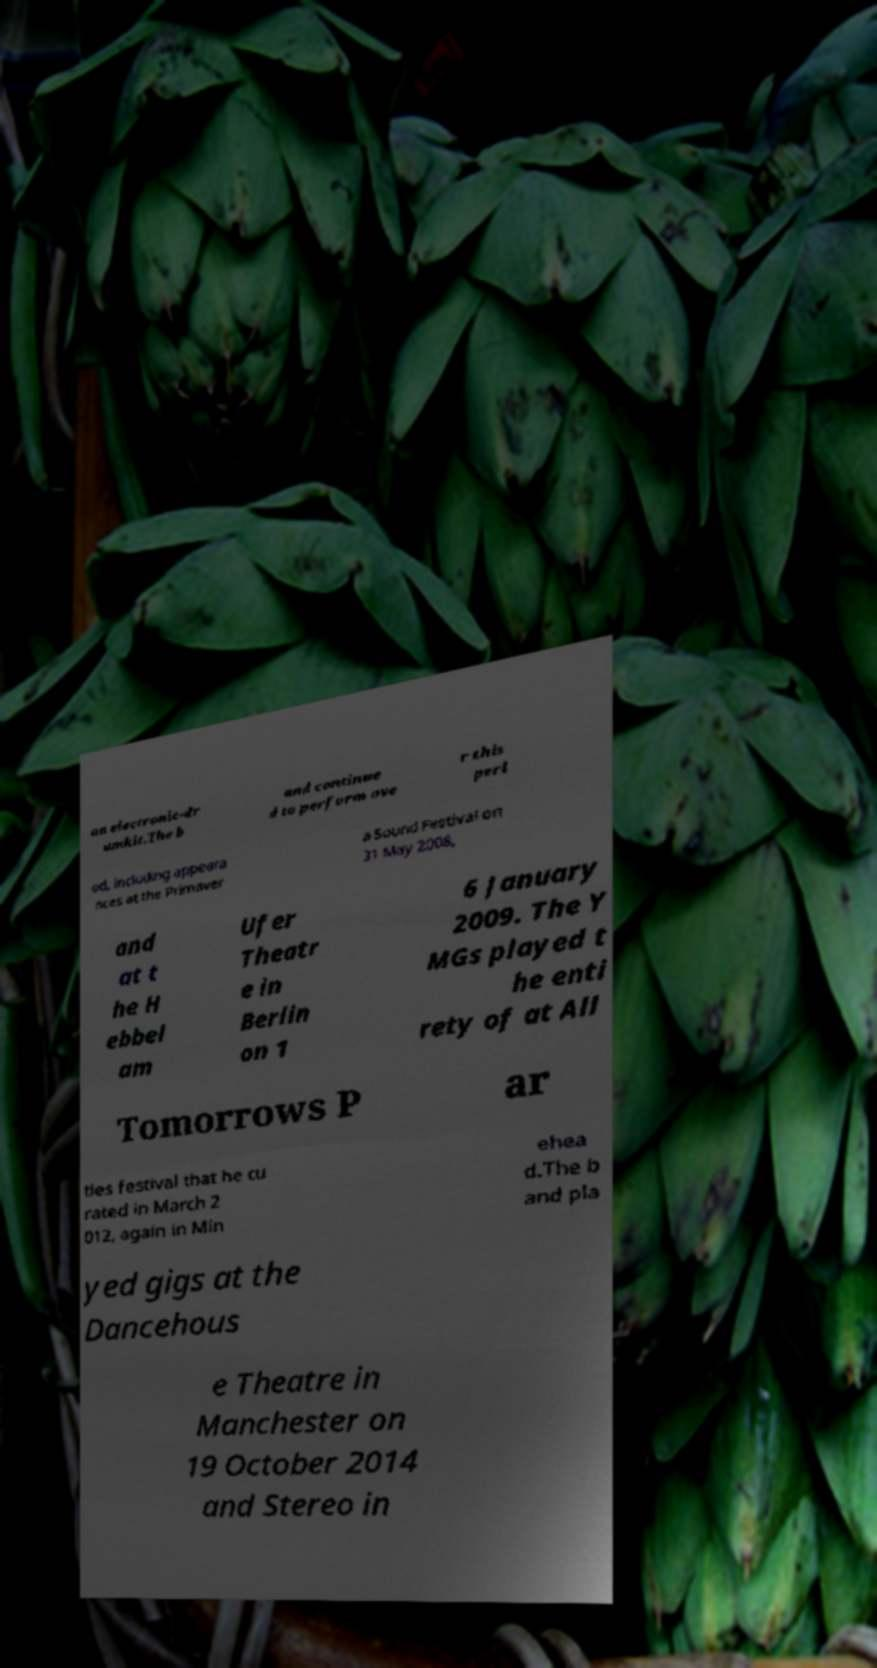Can you read and provide the text displayed in the image?This photo seems to have some interesting text. Can you extract and type it out for me? an electronic-dr umkit.The b and continue d to perform ove r this peri od, including appeara nces at the Primaver a Sound Festival on 31 May 2008, and at t he H ebbel am Ufer Theatr e in Berlin on 1 6 January 2009. The Y MGs played t he enti rety of at All Tomorrows P ar ties festival that he cu rated in March 2 012, again in Min ehea d.The b and pla yed gigs at the Dancehous e Theatre in Manchester on 19 October 2014 and Stereo in 